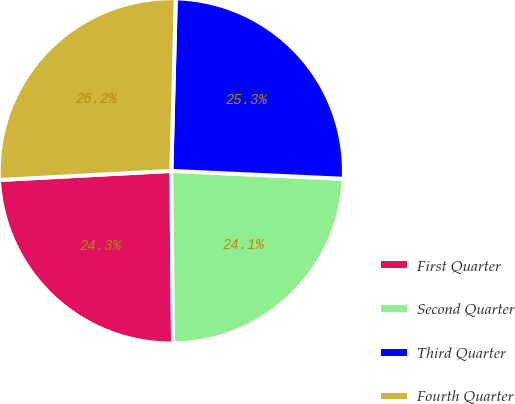Convert chart to OTSL. <chart><loc_0><loc_0><loc_500><loc_500><pie_chart><fcel>First Quarter<fcel>Second Quarter<fcel>Third Quarter<fcel>Fourth Quarter<nl><fcel>24.32%<fcel>24.11%<fcel>25.32%<fcel>26.25%<nl></chart> 